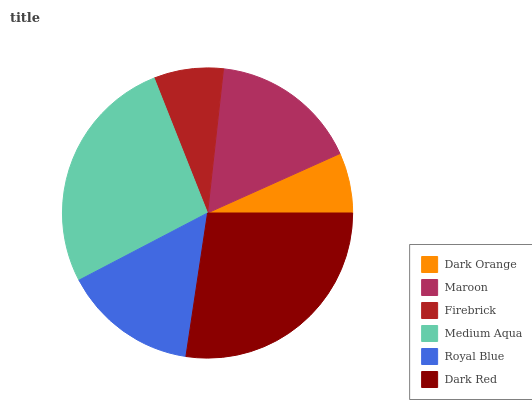Is Dark Orange the minimum?
Answer yes or no. Yes. Is Dark Red the maximum?
Answer yes or no. Yes. Is Maroon the minimum?
Answer yes or no. No. Is Maroon the maximum?
Answer yes or no. No. Is Maroon greater than Dark Orange?
Answer yes or no. Yes. Is Dark Orange less than Maroon?
Answer yes or no. Yes. Is Dark Orange greater than Maroon?
Answer yes or no. No. Is Maroon less than Dark Orange?
Answer yes or no. No. Is Maroon the high median?
Answer yes or no. Yes. Is Royal Blue the low median?
Answer yes or no. Yes. Is Firebrick the high median?
Answer yes or no. No. Is Firebrick the low median?
Answer yes or no. No. 